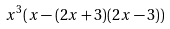Convert formula to latex. <formula><loc_0><loc_0><loc_500><loc_500>x ^ { 3 } ( x - ( 2 x + 3 ) ( 2 x - 3 ) )</formula> 